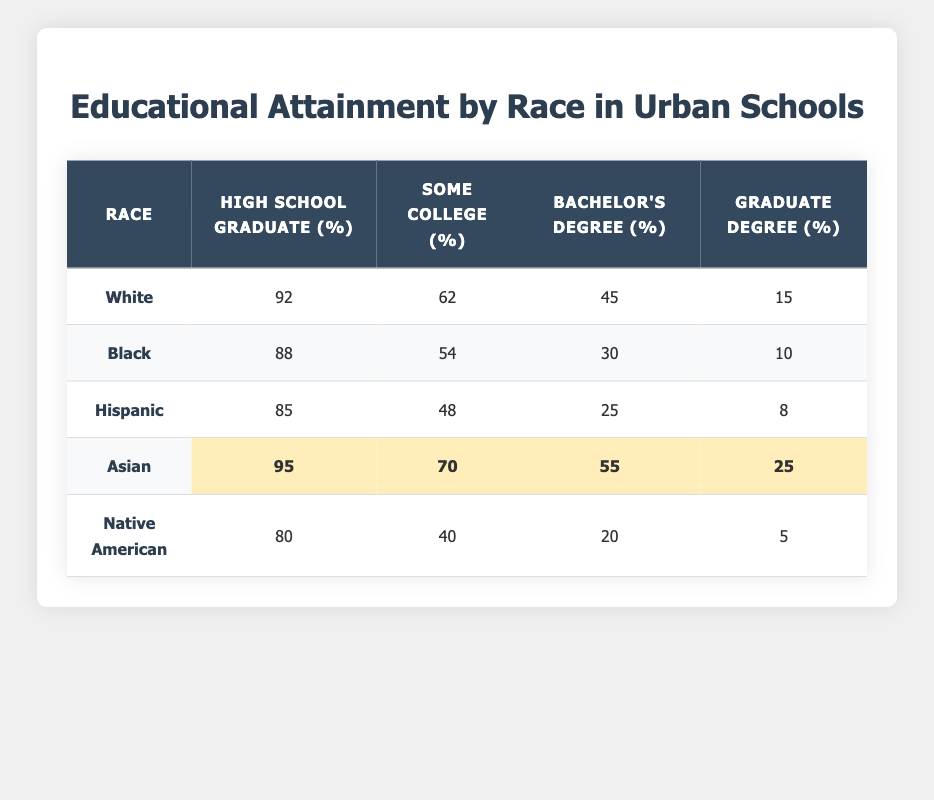What percentage of White students are high school graduates? According to the table, the percentage of White students who are high school graduates is listed as 92%.
Answer: 92% What is the percentage of Hispanic students with a graduate degree? The table indicates that 8% of Hispanic students have a graduate degree.
Answer: 8% Which group has the highest percentage of individuals with a bachelor's degree? The table shows that Asian students have the highest percentage at 55%.
Answer: Asian What is the difference in the percentage of high school graduates between Asian and Native American students? For Asian students, the high school graduation rate is 95%, while for Native American students, it's 80%. The difference is 95% - 80% = 15%.
Answer: 15% Are there more students with some college experience in the Asian group compared to the Black group? The table lists 70% of Asian students with some college experience, compared to 54% of Black students. Therefore, there are more in the Asian group.
Answer: Yes What is the average percentage of high school graduates across all races listed? The percentages of high school graduates are 92, 88, 85, 95, and 80. Adding these gives a total of 440. Dividing by 5 (the number of groups) gives an average of 88%.
Answer: 88% Is it true that no group has more than 10% of students with a graduate degree? Looking at the table, we see that 15% of White students and 25% of Asian students have a graduate degree, which means the statement is false.
Answer: No What percentage of Black students have a bachelor's degree compared to Hispanic students? The table shows that 30% of Black students have a bachelor's degree, while 25% of Hispanic students do. Black students have a higher percentage by 5%.
Answer: Yes, 5% higher How many more students with some college experience are there in the Asian group than in the Native American group? The table states that 70% of Asian students have some college experience and 40% of Native American students do. The difference is 70% - 40% = 30%.
Answer: 30% Which racial group has the lowest percentage of high school graduates? The lowest percentage of high school graduates is for Native American students at 80%.
Answer: Native American 